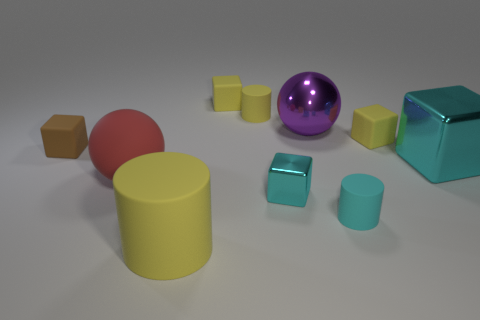Subtract 2 cubes. How many cubes are left? 3 Subtract all brown cubes. How many cubes are left? 4 Subtract all brown rubber cubes. How many cubes are left? 4 Subtract all red blocks. Subtract all yellow spheres. How many blocks are left? 5 Subtract all cylinders. How many objects are left? 7 Add 8 big rubber cylinders. How many big rubber cylinders exist? 9 Subtract 0 purple cubes. How many objects are left? 10 Subtract all big cyan objects. Subtract all matte cubes. How many objects are left? 6 Add 8 large cyan metallic objects. How many large cyan metallic objects are left? 9 